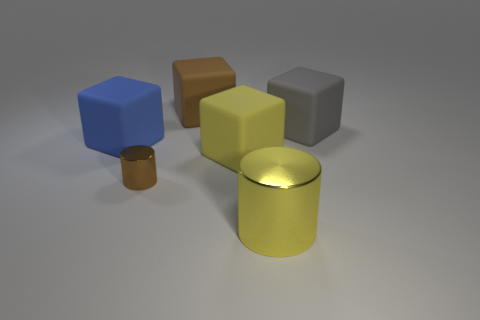Subtract 1 blocks. How many blocks are left? 3 Add 1 large blue rubber objects. How many objects exist? 7 Subtract all cylinders. How many objects are left? 4 Subtract 0 cyan cylinders. How many objects are left? 6 Subtract all shiny cylinders. Subtract all large gray blocks. How many objects are left? 3 Add 3 large blue things. How many large blue things are left? 4 Add 6 large metallic cylinders. How many large metallic cylinders exist? 7 